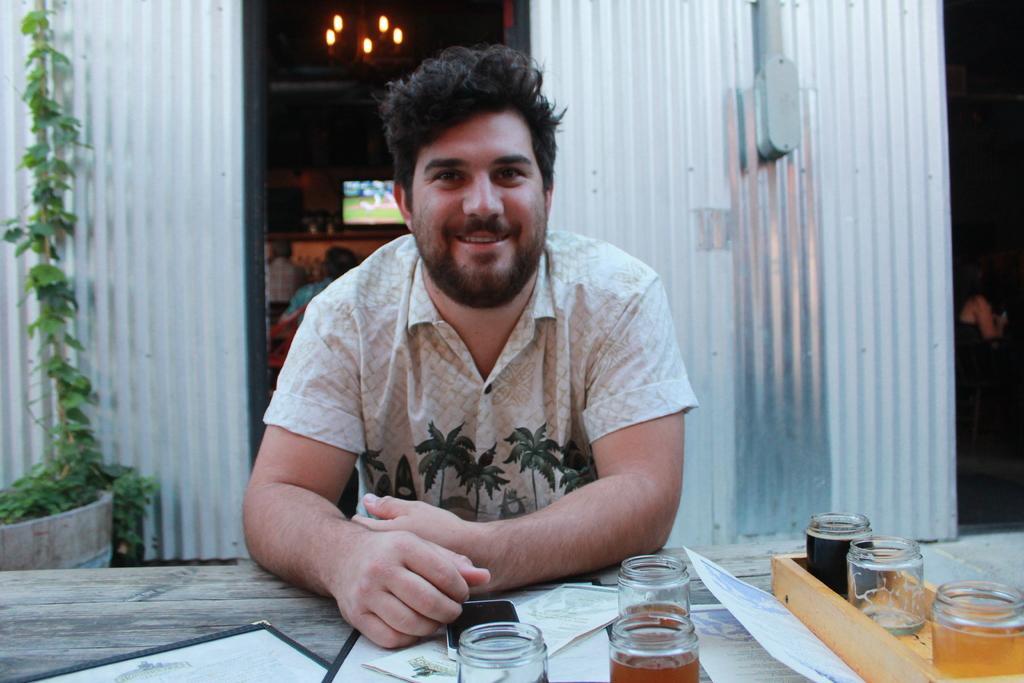How would you summarize this image in a sentence or two? In this image i can see a man is sitting on a chair in front of a table. On the table we have few objects on it. 